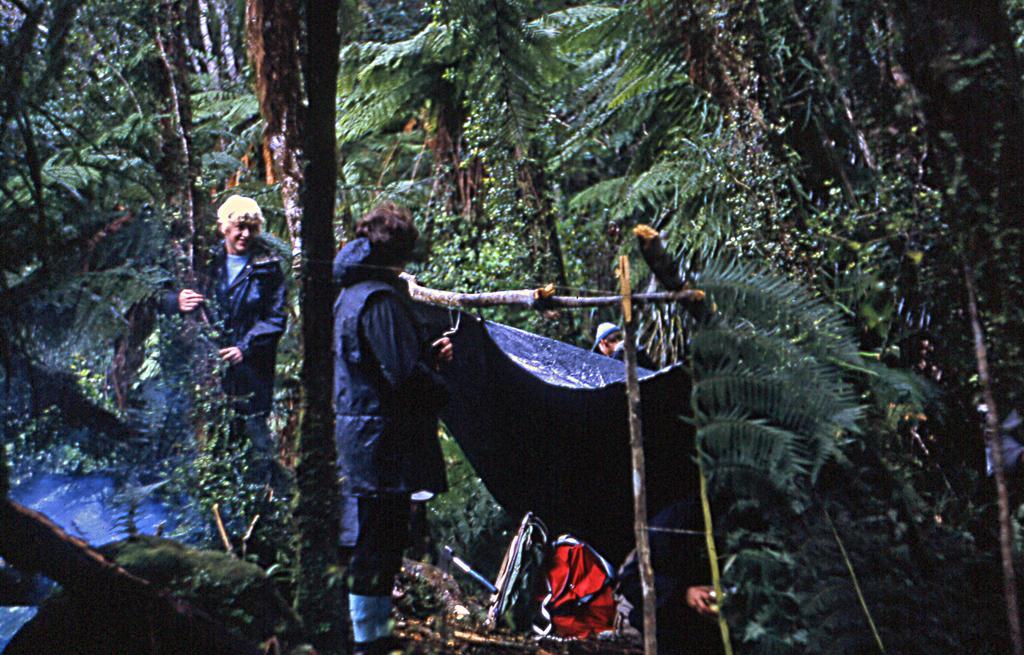Could you give a brief overview of what you see in this image? In this image there are a few people standing around them there are trees and they have made a tent with wooden sticks as pillars, on the surface there are some objects. 